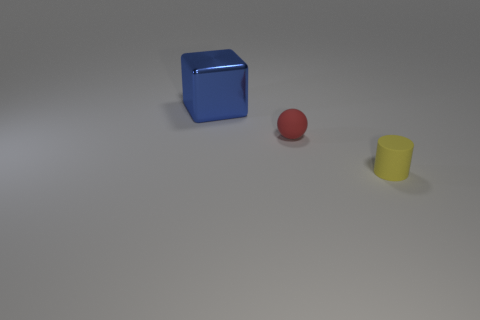Is there any other thing that is made of the same material as the cube?
Offer a terse response. No. There is a red object that is made of the same material as the yellow object; what is its shape?
Make the answer very short. Sphere. Are there fewer big metal objects in front of the tiny red matte thing than yellow rubber cylinders that are on the left side of the cylinder?
Keep it short and to the point. No. Is the number of large green metallic cylinders greater than the number of small balls?
Make the answer very short. No. What material is the blue cube?
Offer a very short reply. Metal. What color is the object that is in front of the tiny sphere?
Make the answer very short. Yellow. Is the number of yellow rubber cylinders in front of the cylinder greater than the number of shiny things that are right of the small red rubber thing?
Offer a very short reply. No. There is a rubber object that is on the right side of the rubber thing that is behind the tiny object that is in front of the ball; how big is it?
Provide a short and direct response. Small. Is there a object that has the same color as the cylinder?
Provide a succinct answer. No. What number of yellow matte cubes are there?
Provide a short and direct response. 0. 